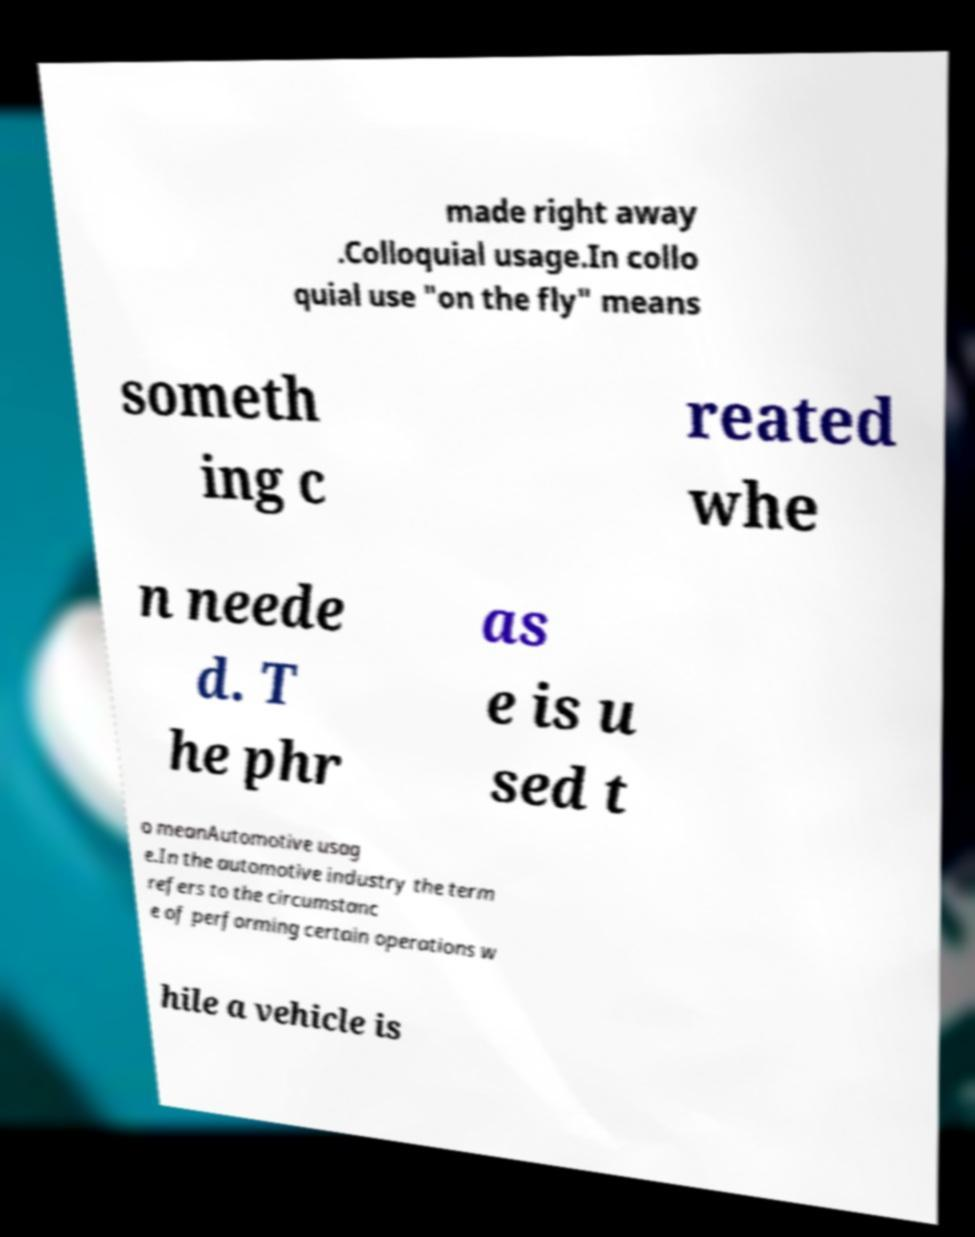Could you extract and type out the text from this image? made right away .Colloquial usage.In collo quial use "on the fly" means someth ing c reated whe n neede d. T he phr as e is u sed t o meanAutomotive usag e.In the automotive industry the term refers to the circumstanc e of performing certain operations w hile a vehicle is 